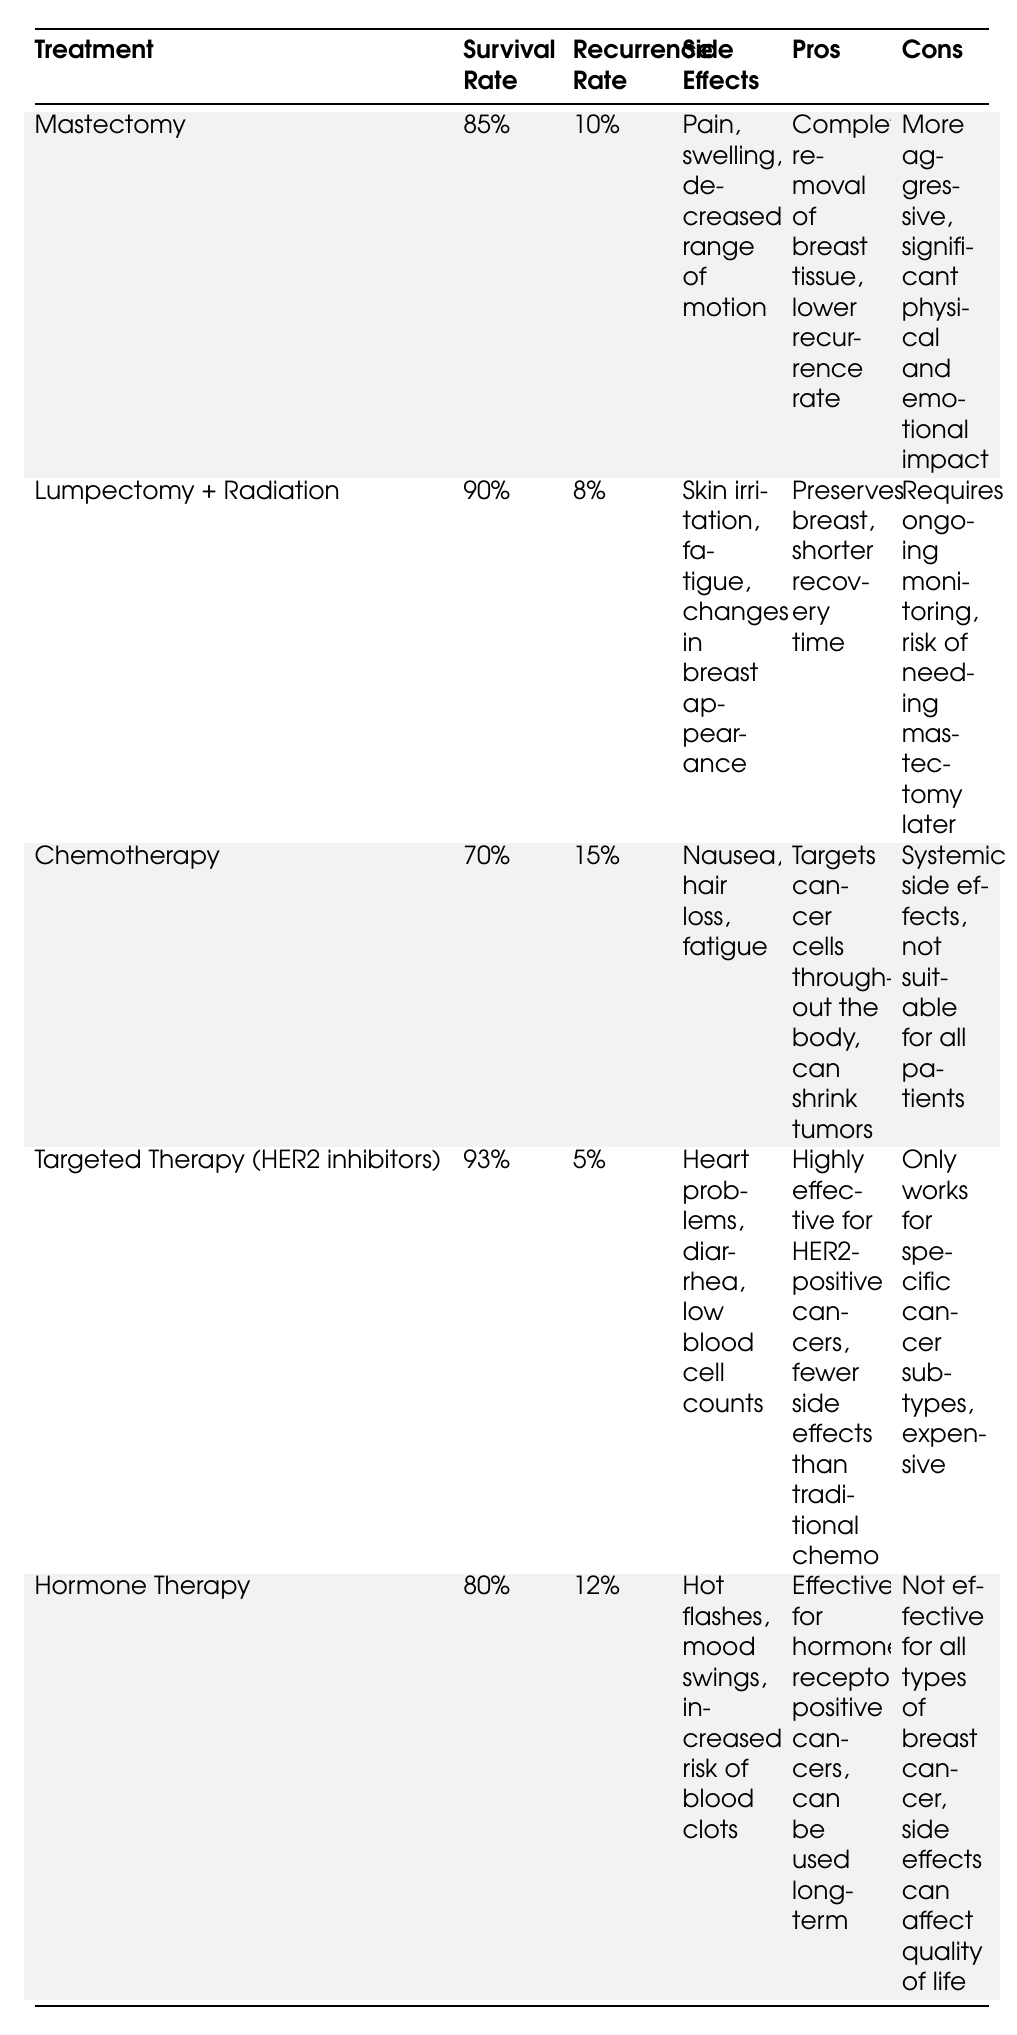What's the average survival rate for Mastectomy? The average survival rate for Mastectomy is provided directly in the table and is stated as 85%.
Answer: 85% Which treatment method has the lowest recurrence rate? By comparing the recurrence rates in the table, Targeted Therapy has the lowest recurrence rate at 5%.
Answer: Targeted Therapy What side effect is common to both Chemotherapy and Hormone Therapy? The side effects for both Chemotherapy and Hormone Therapy are listed in the table. They include general side effects like fatigue, making it common between the two.
Answer: Fatigue What is the survival rate difference between Lumpectomy + Radiation and Hormone Therapy? The survival rate for Lumpectomy + Radiation is 90%, while for Hormone Therapy it is 80%. The difference is therefore 90% - 80% = 10%.
Answer: 10% Is the average survival rate for Targeted Therapy higher than that for Mastectomy? The average survival rate for Targeted Therapy is 93%, which is higher than the survival rate of 85% for Mastectomy.
Answer: Yes How many methods have a survival rate above 85%? The methods with a survival rate above 85% are Lumpectomy + Radiation (90%), Targeted Therapy (93%), and Mastectomy (85%). There are three methods in total.
Answer: 3 What is the average recurrence rate of all listed treatment methods? Adding the recurrence rates (10% + 8% + 15% + 5% + 12%) gives 50%. Dividing by the number of methods (5) results in an average of 50%/5 = 10%.
Answer: 10% Which treatment has the most significant physical impact according to the cons? The cons for Mastectomy specifically mention a significant physical and emotional impact, distinguishing it as having the most significant impact.
Answer: Mastectomy If a patient opts for Hormone Therapy, what are the potential side effects they might experience? The side effects for Hormone Therapy listed in the table are hot flashes, mood swings, and an increased risk of blood clots.
Answer: Hot flashes, mood swings, risk of blood clots What is the combination of pros and cons that makes Lumpectomy + Radiation a preferable option despite needing to monitor it continually? The pros of Lumpectomy + Radiation include preserving the breast and having a shorter recovery time. The cons mention the need for ongoing monitoring and the risk of a future mastectomy, but the advantages may outweigh these concerns for many patients.
Answer: Preserves breast, shorter recovery time, ongoing monitoring needed 